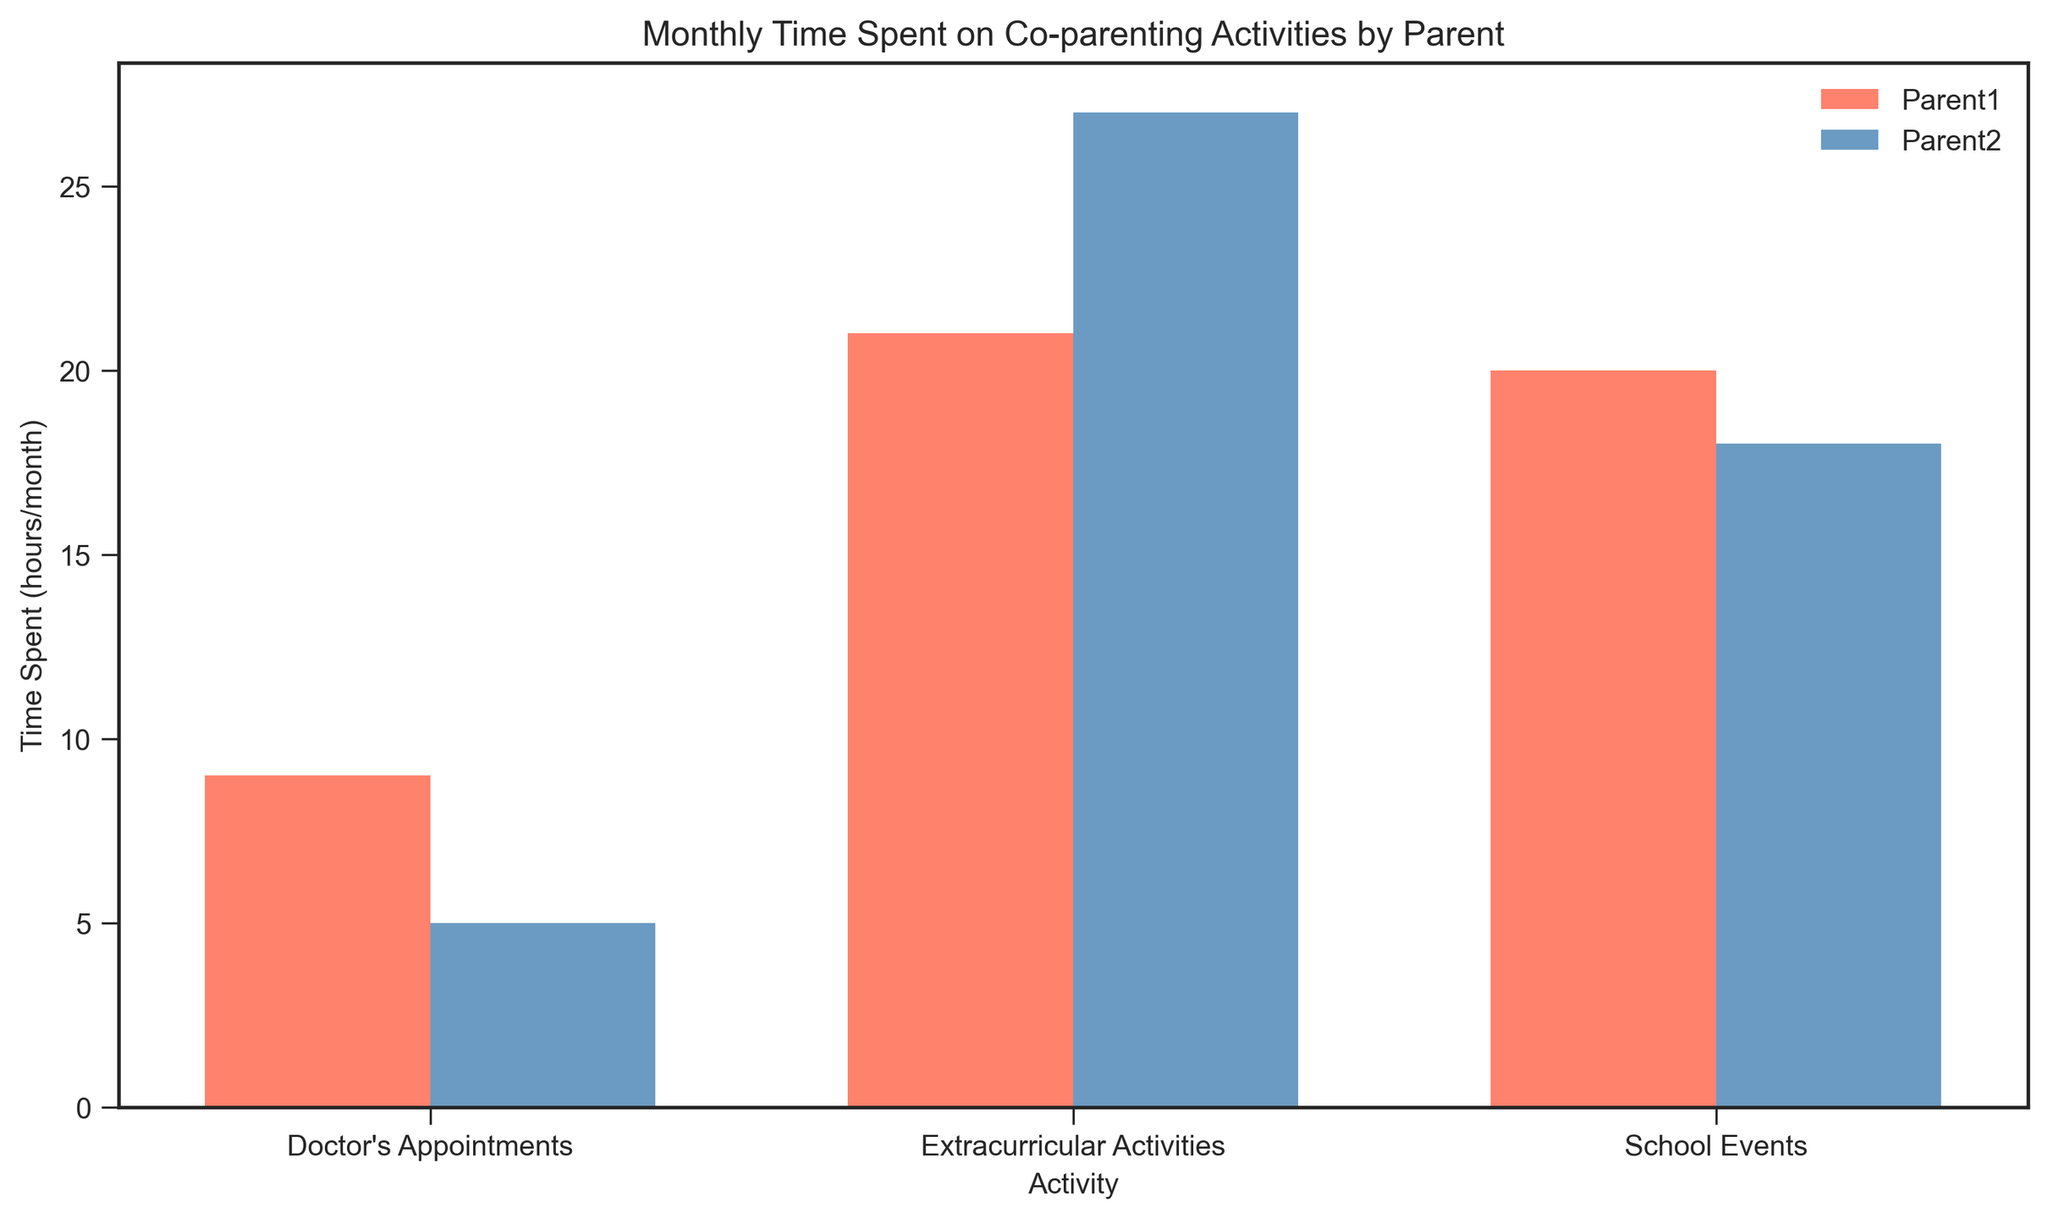How many total hours did Parent1 spend on all activities combined? To find this, sum the hours spent by Parent1 on School Events, Extracurricular Activities, and Doctor's Appointments. Adding up these hours, we get 5 + 8 + 2 + 7 + 6 + 3 + 8 + 7 + 4 = 50 hours.
Answer: 50 Which parent spent more total time attending School Events? Compare the total time spent on School Events by Parent1 and Parent2. Parent1 spent 5 + 7 + 8 = 20 hours while Parent2 spent 6 + 5 + 7 = 18 hours. Therefore, Parent1 spent more time.
Answer: Parent1 On which activity did Parent2 spend the least time? Examine the total hours spent by Parent2 on each activity: School Events (6 + 5 + 7 = 18 hours), Extracurricular Activities (9 + 10 + 8 = 27 hours), and Doctor's Appointments (2 + 1 + 2 = 5 hours). The least time was spent on Doctor's Appointments.
Answer: Doctor's Appointments By how many hours does Parent2’s time spent on Extracurricular Activities exceed that of Parent1? Sum Parent2's and Parent1's time on Extracurricular Activities: Parent2 (9 + 10 + 8 = 27 hours) and Parent1 (8 + 6 + 7 = 21 hours). The difference is 27 - 21 = 6 hours.
Answer: 6 Which activity has the most combined time spent by both parents? Calculate the total combined hours for each activity: School Events (20 + 18 = 38 hours), Extracurricular Activities (21 + 27 = 48 hours), and Doctor's Appointments (9 + 5 = 14 hours). The most time was spent on Extracurricular Activities.
Answer: Extracurricular Activities Which parent spent more time on Doctor's Appointments? Compare the total time spent on Doctor's Appointments by Parent1 and Parent2. Parent1's total is 2 + 3 + 4 = 9 hours, whereas Parent2's total is 2 + 1 + 2 = 5 hours. Thus, Parent1 spent more time.
Answer: Parent1 What is the average time spent on School Events by both parents? Add up the times spent on School Events by both parents: (5 + 7 + 8 + 6 + 5 + 7 = 38 hours). Divide by the number of data points: 38 / 6 ≈ 6.33 hours.
Answer: 6.33 In which activity do the parents' total time differ the most? Calculate the absolute differences in total time for each activity: School Events (20 - 18 = 2 hours), Extracurricular Activities (27 - 21 = 6 hours), Doctor's Appointments (9 - 5 = 4 hours). The greatest difference is in Extracurricular Activities.
Answer: Extracurricular Activities 